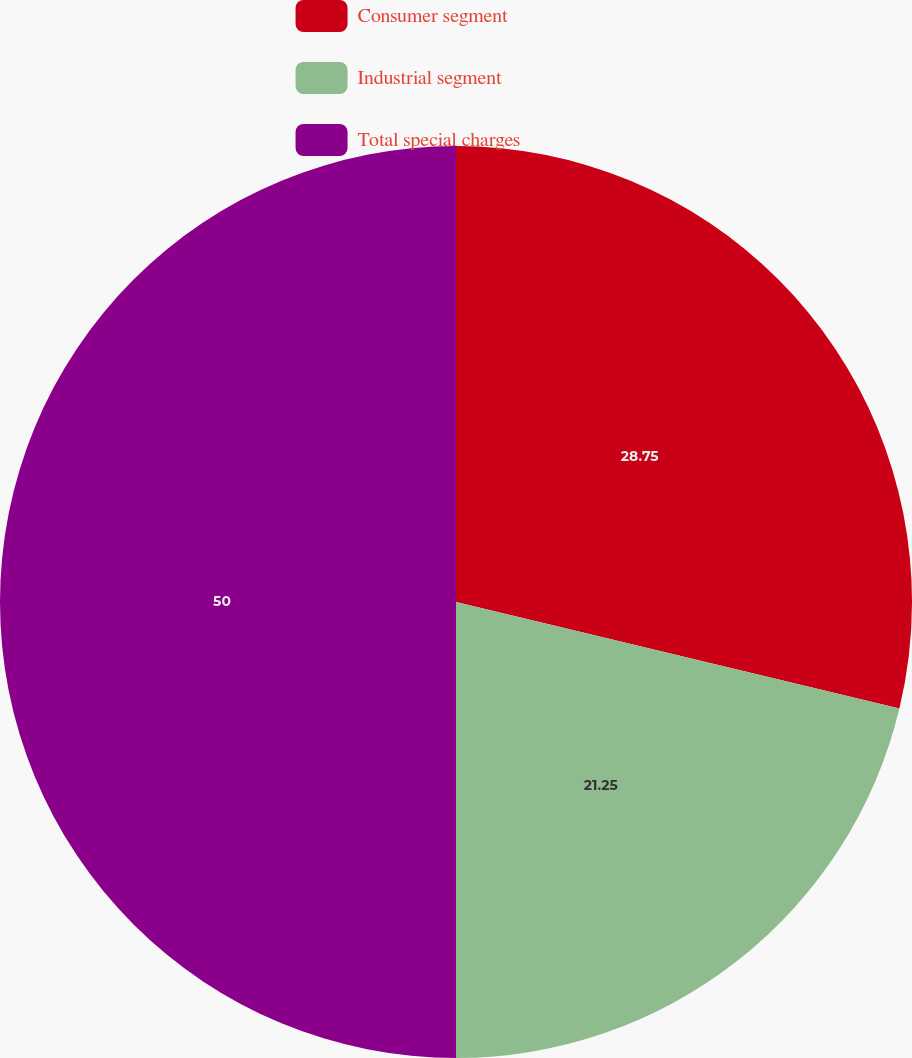Convert chart. <chart><loc_0><loc_0><loc_500><loc_500><pie_chart><fcel>Consumer segment<fcel>Industrial segment<fcel>Total special charges<nl><fcel>28.75%<fcel>21.25%<fcel>50.0%<nl></chart> 